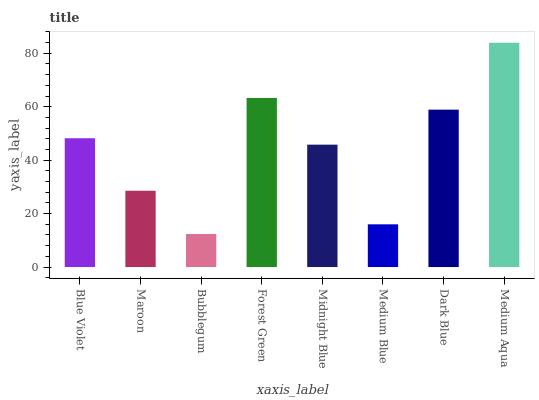Is Maroon the minimum?
Answer yes or no. No. Is Maroon the maximum?
Answer yes or no. No. Is Blue Violet greater than Maroon?
Answer yes or no. Yes. Is Maroon less than Blue Violet?
Answer yes or no. Yes. Is Maroon greater than Blue Violet?
Answer yes or no. No. Is Blue Violet less than Maroon?
Answer yes or no. No. Is Blue Violet the high median?
Answer yes or no. Yes. Is Midnight Blue the low median?
Answer yes or no. Yes. Is Bubblegum the high median?
Answer yes or no. No. Is Medium Blue the low median?
Answer yes or no. No. 